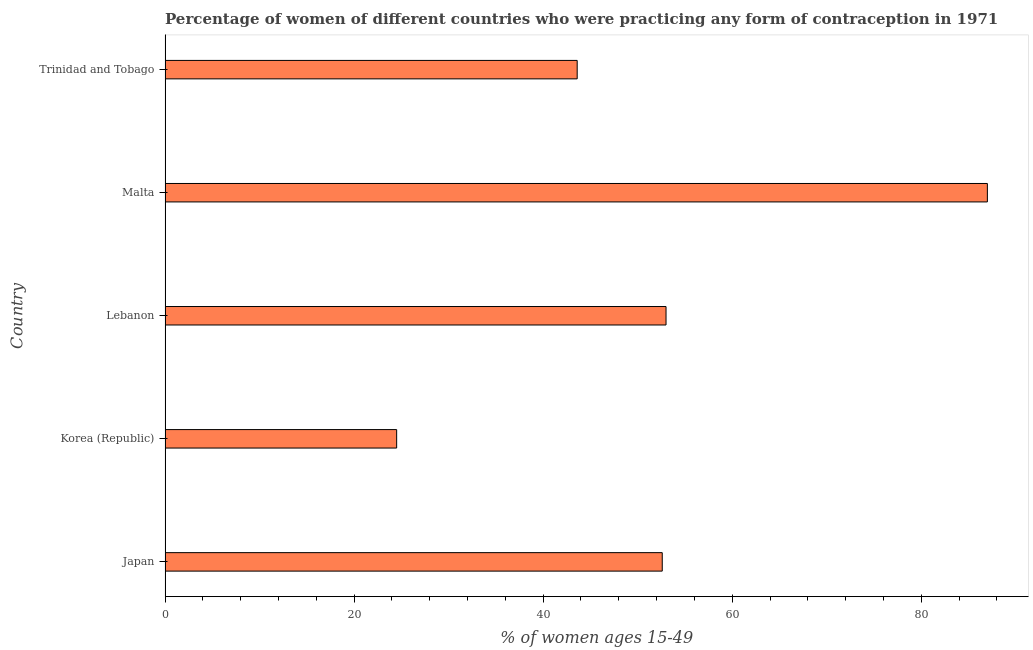Does the graph contain grids?
Keep it short and to the point. No. What is the title of the graph?
Ensure brevity in your answer.  Percentage of women of different countries who were practicing any form of contraception in 1971. What is the label or title of the X-axis?
Offer a terse response. % of women ages 15-49. What is the contraceptive prevalence in Japan?
Your answer should be very brief. 52.6. Across all countries, what is the maximum contraceptive prevalence?
Give a very brief answer. 87. In which country was the contraceptive prevalence maximum?
Provide a short and direct response. Malta. In which country was the contraceptive prevalence minimum?
Provide a succinct answer. Korea (Republic). What is the sum of the contraceptive prevalence?
Give a very brief answer. 260.7. What is the difference between the contraceptive prevalence in Malta and Trinidad and Tobago?
Offer a very short reply. 43.4. What is the average contraceptive prevalence per country?
Make the answer very short. 52.14. What is the median contraceptive prevalence?
Provide a succinct answer. 52.6. In how many countries, is the contraceptive prevalence greater than 76 %?
Your answer should be compact. 1. What is the ratio of the contraceptive prevalence in Lebanon to that in Trinidad and Tobago?
Give a very brief answer. 1.22. Is the contraceptive prevalence in Lebanon less than that in Malta?
Your answer should be very brief. Yes. Is the sum of the contraceptive prevalence in Lebanon and Malta greater than the maximum contraceptive prevalence across all countries?
Your answer should be very brief. Yes. What is the difference between the highest and the lowest contraceptive prevalence?
Your answer should be very brief. 62.5. How many bars are there?
Provide a short and direct response. 5. Are all the bars in the graph horizontal?
Make the answer very short. Yes. Are the values on the major ticks of X-axis written in scientific E-notation?
Provide a succinct answer. No. What is the % of women ages 15-49 of Japan?
Your answer should be compact. 52.6. What is the % of women ages 15-49 in Lebanon?
Offer a very short reply. 53. What is the % of women ages 15-49 in Malta?
Offer a terse response. 87. What is the % of women ages 15-49 of Trinidad and Tobago?
Keep it short and to the point. 43.6. What is the difference between the % of women ages 15-49 in Japan and Korea (Republic)?
Your answer should be very brief. 28.1. What is the difference between the % of women ages 15-49 in Japan and Lebanon?
Provide a succinct answer. -0.4. What is the difference between the % of women ages 15-49 in Japan and Malta?
Offer a terse response. -34.4. What is the difference between the % of women ages 15-49 in Japan and Trinidad and Tobago?
Your answer should be very brief. 9. What is the difference between the % of women ages 15-49 in Korea (Republic) and Lebanon?
Give a very brief answer. -28.5. What is the difference between the % of women ages 15-49 in Korea (Republic) and Malta?
Give a very brief answer. -62.5. What is the difference between the % of women ages 15-49 in Korea (Republic) and Trinidad and Tobago?
Your answer should be very brief. -19.1. What is the difference between the % of women ages 15-49 in Lebanon and Malta?
Provide a succinct answer. -34. What is the difference between the % of women ages 15-49 in Lebanon and Trinidad and Tobago?
Give a very brief answer. 9.4. What is the difference between the % of women ages 15-49 in Malta and Trinidad and Tobago?
Your answer should be very brief. 43.4. What is the ratio of the % of women ages 15-49 in Japan to that in Korea (Republic)?
Offer a very short reply. 2.15. What is the ratio of the % of women ages 15-49 in Japan to that in Malta?
Ensure brevity in your answer.  0.6. What is the ratio of the % of women ages 15-49 in Japan to that in Trinidad and Tobago?
Provide a short and direct response. 1.21. What is the ratio of the % of women ages 15-49 in Korea (Republic) to that in Lebanon?
Offer a terse response. 0.46. What is the ratio of the % of women ages 15-49 in Korea (Republic) to that in Malta?
Ensure brevity in your answer.  0.28. What is the ratio of the % of women ages 15-49 in Korea (Republic) to that in Trinidad and Tobago?
Your response must be concise. 0.56. What is the ratio of the % of women ages 15-49 in Lebanon to that in Malta?
Provide a succinct answer. 0.61. What is the ratio of the % of women ages 15-49 in Lebanon to that in Trinidad and Tobago?
Your response must be concise. 1.22. What is the ratio of the % of women ages 15-49 in Malta to that in Trinidad and Tobago?
Offer a very short reply. 2. 